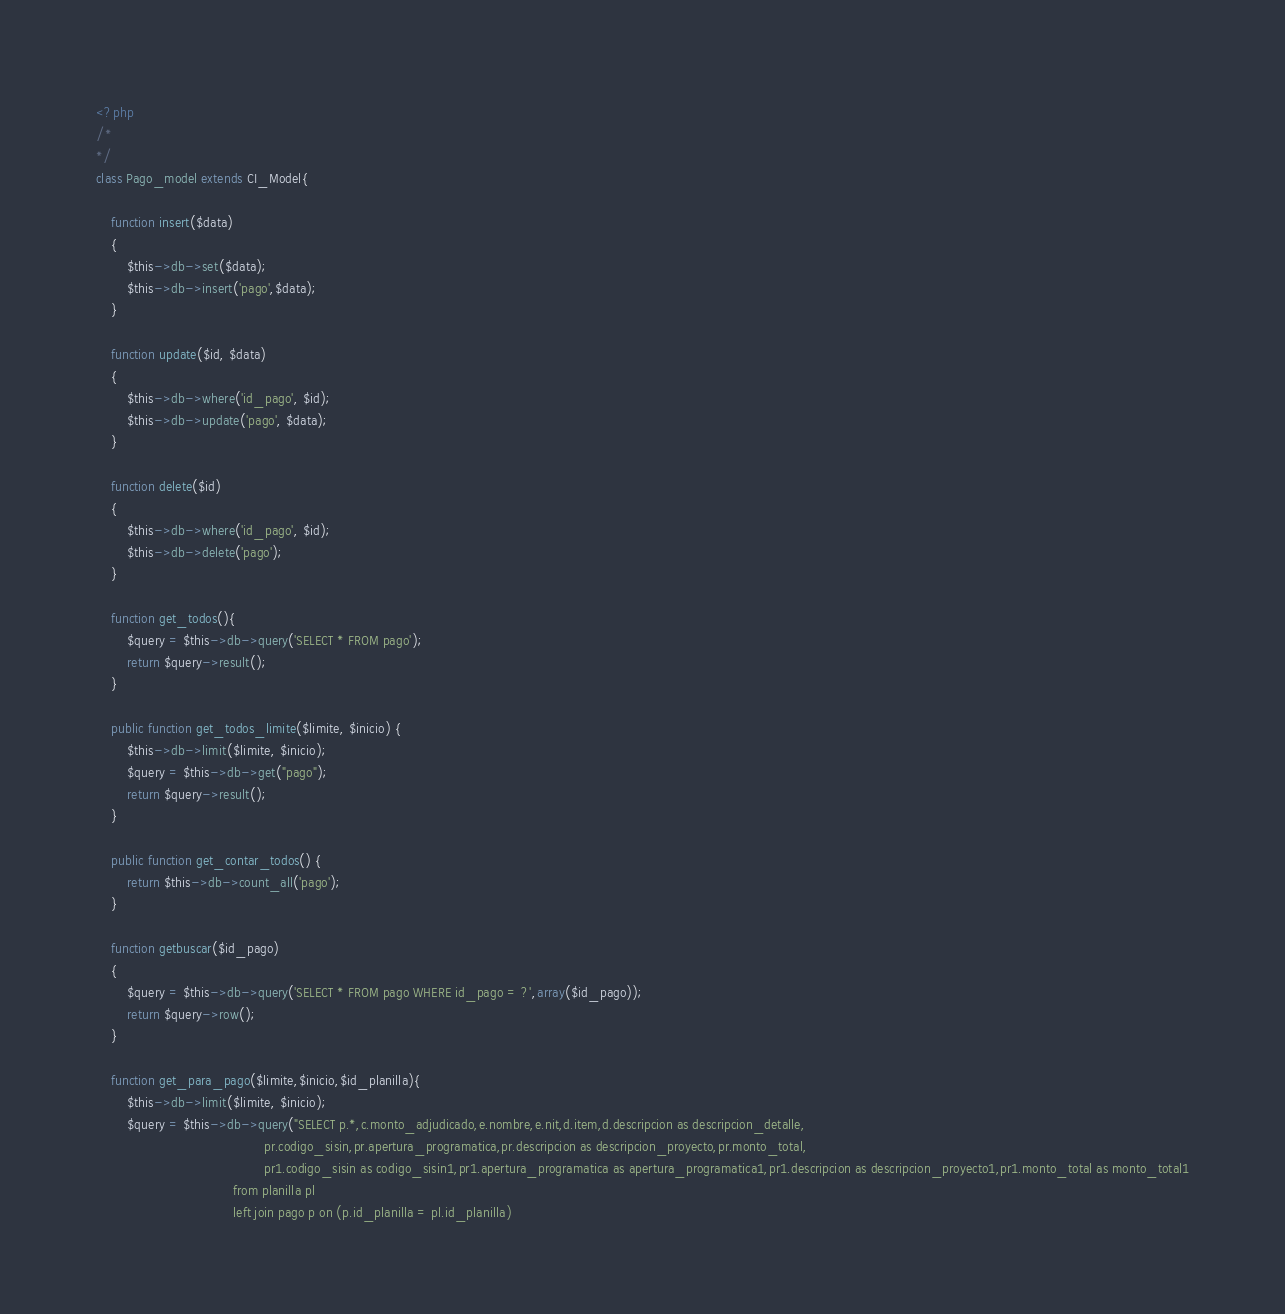Convert code to text. <code><loc_0><loc_0><loc_500><loc_500><_PHP_><?php
/*
*/
class Pago_model extends CI_Model{
    
    function insert($data)
    {
        $this->db->set($data);
        $this->db->insert('pago',$data);
    }

    function update($id, $data)
    {
        $this->db->where('id_pago', $id);
        $this->db->update('pago', $data);        
    }

    function delete($id)
    {
		$this->db->where('id_pago', $id);
		$this->db->delete('pago');
    }
    
    function get_todos(){
        $query = $this->db->query('SELECT * FROM pago');
        return $query->result();
    }
    
    public function get_todos_limite($limite, $inicio) {
        $this->db->limit($limite, $inicio);
        $query = $this->db->get("pago");        
        return $query->result();
    }
    
    public function get_contar_todos() {        
        return $this->db->count_all('pago');
    }
    
    function getbuscar($id_pago)
    {
        $query = $this->db->query('SELECT * FROM pago WHERE id_pago = ?',array($id_pago));
        return $query->row();
    }
    
    function get_para_pago($limite,$inicio,$id_planilla){
        $this->db->limit($limite, $inicio);
        $query = $this->db->query("SELECT p.*,c.monto_adjudicado,e.nombre,e.nit,d.item,d.descripcion as descripcion_detalle,
                                            pr.codigo_sisin,pr.apertura_programatica,pr.descripcion as descripcion_proyecto,pr.monto_total,
                                            pr1.codigo_sisin as codigo_sisin1,pr1.apertura_programatica as apertura_programatica1,pr1.descripcion as descripcion_proyecto1,pr1.monto_total as monto_total1
                                    from planilla pl  
                                    left join pago p on (p.id_planilla = pl.id_planilla)</code> 